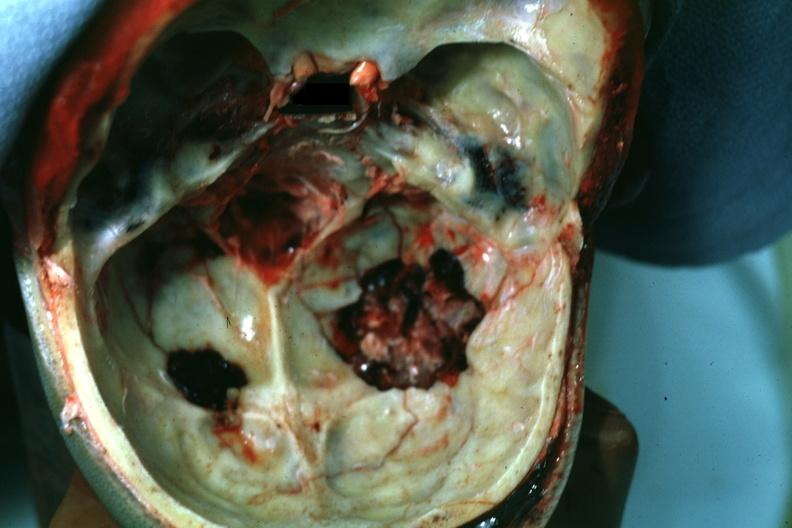does this look more like a gunshot wound?
Answer the question using a single word or phrase. Yes 